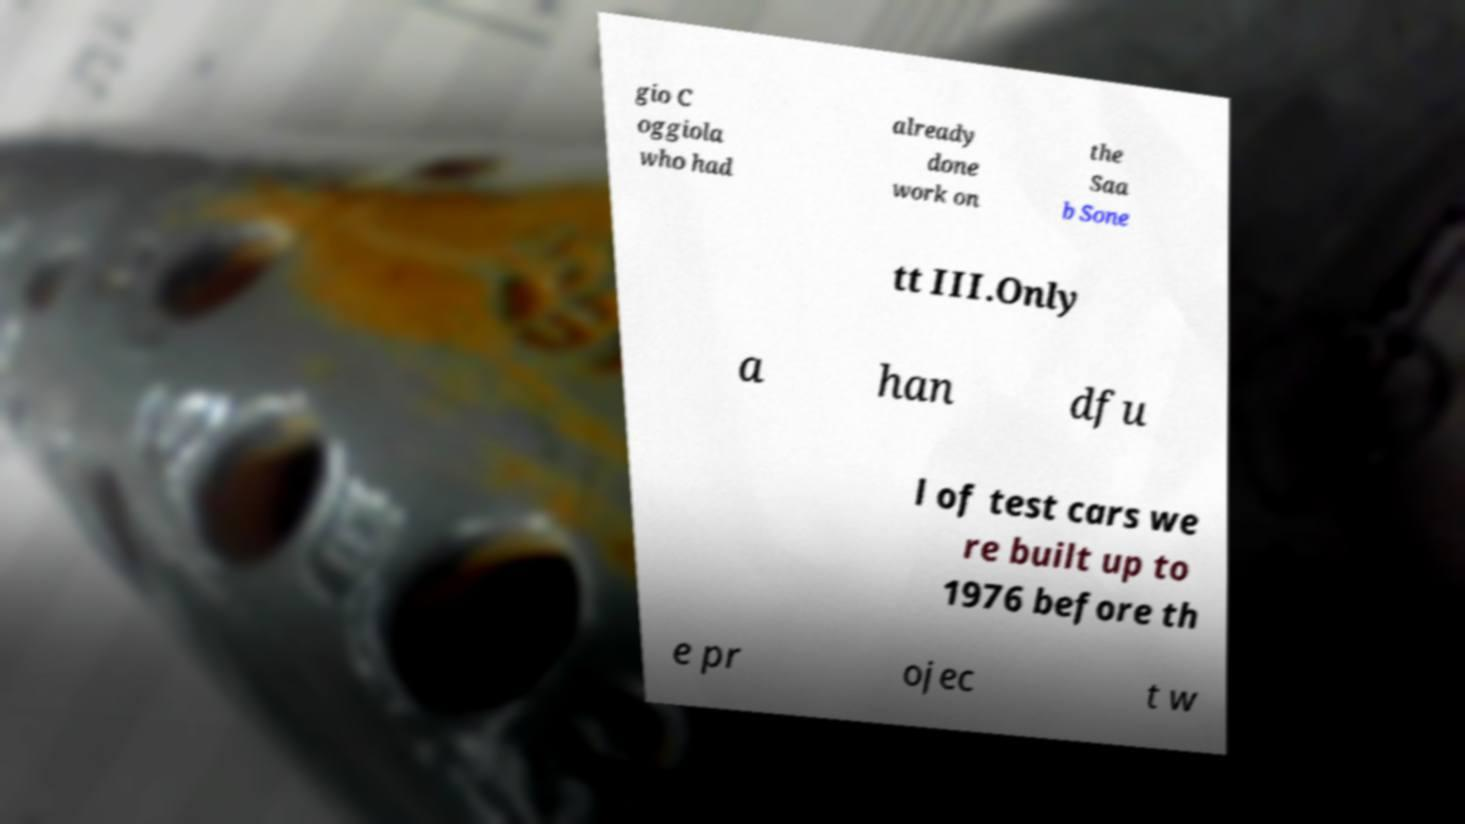Could you extract and type out the text from this image? gio C oggiola who had already done work on the Saa b Sone tt III.Only a han dfu l of test cars we re built up to 1976 before th e pr ojec t w 